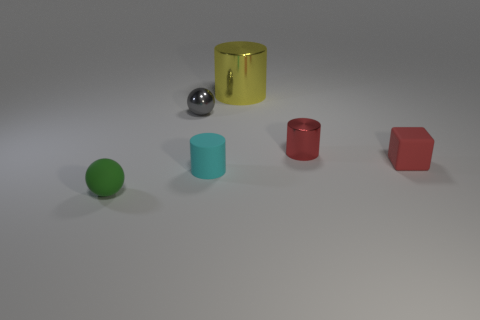There is a cylinder to the right of the big metal thing; is it the same color as the cylinder to the left of the yellow object?
Your answer should be very brief. No. What is the size of the green matte object that is the same shape as the small gray shiny object?
Provide a succinct answer. Small. Do the tiny cylinder in front of the red cylinder and the cylinder on the right side of the yellow metallic thing have the same material?
Your answer should be compact. No. What number of rubber objects are large gray cylinders or large yellow objects?
Your answer should be compact. 0. The object that is on the left side of the tiny metallic object on the left side of the small cylinder that is left of the big object is made of what material?
Your response must be concise. Rubber. Does the tiny shiny thing on the left side of the big yellow shiny cylinder have the same shape as the small red thing that is to the left of the block?
Your response must be concise. No. There is a shiny cylinder that is in front of the small sphere that is behind the green rubber object; what is its color?
Ensure brevity in your answer.  Red. What number of cylinders are either matte objects or green objects?
Make the answer very short. 1. How many red cubes are behind the tiny shiny object that is to the left of the shiny cylinder that is on the left side of the red cylinder?
Your answer should be compact. 0. There is a cylinder that is the same color as the tiny matte block; what size is it?
Make the answer very short. Small. 